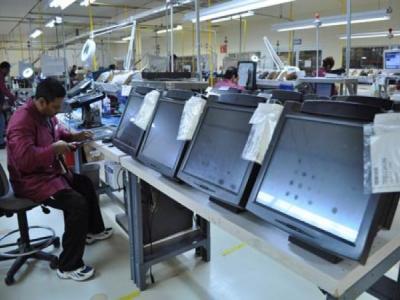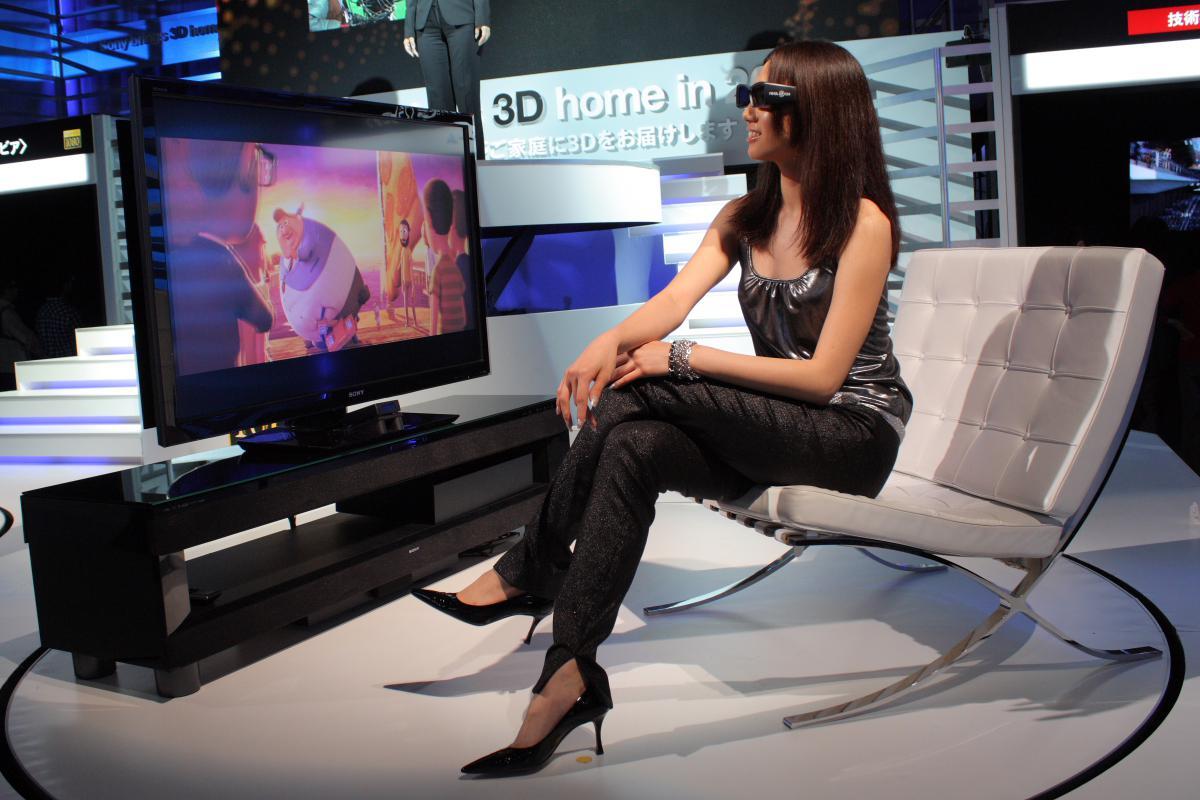The first image is the image on the left, the second image is the image on the right. Examine the images to the left and right. Is the description "The right image contains two humans." accurate? Answer yes or no. No. 